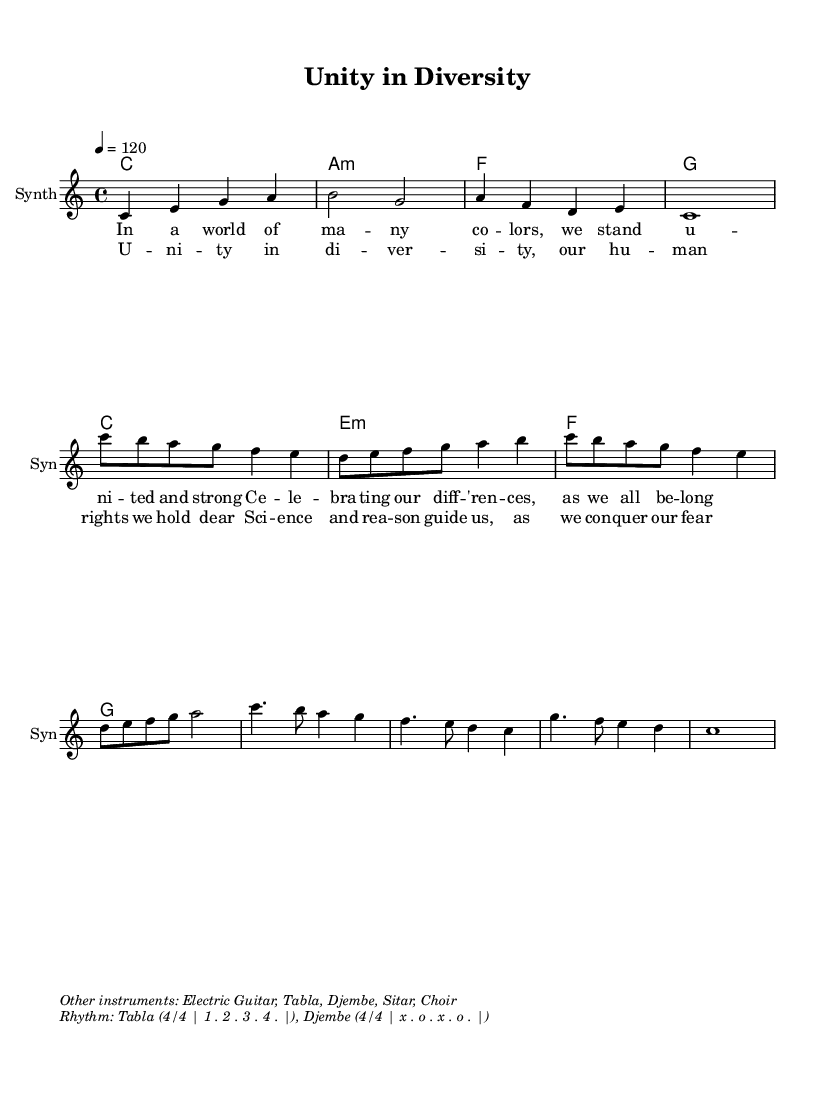What is the key signature of this music? The key signature is indicated as C major, which has no sharps or flats, visible in the music sheet where no accidentals are present.
Answer: C major What is the time signature of this music? The time signature is shown as 4/4, which is a common time signature in Western music, easily identifiable near the beginning of the score.
Answer: 4/4 What is the tempo marking of this piece? The tempo marking indicates a speed of 120 beats per minute, mentioned within the initial tempo indication of the score.
Answer: 120 How many measures are in the chorus section? By counting the measures specifically within the chorus lyrics, there are four distinct measures represented in that section of the music.
Answer: 4 What instruments are indicated in the additional markup? The sheet music mentions Electric Guitar, Tabla, Djembe, Sitar, and Choir as additional instruments, listed in the markup section below the main score.
Answer: Electric Guitar, Tabla, Djembe, Sitar, Choir Explain the significance of "Unity in Diversity" based on musical elements. "Unity in Diversity" is reflected in the use of varied instruments (like Tabla and Djembe) creating a fusion sound that celebrates cultural differences, supporting the theme of unity through diversity in the composition. The combination of electronic and world music elements emphasizes this theme by blending different musical traditions.
Answer: Cultural diversity and celebration 